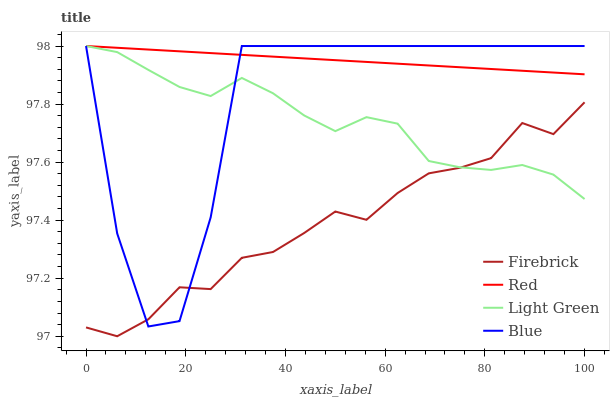Does Firebrick have the minimum area under the curve?
Answer yes or no. Yes. Does Red have the maximum area under the curve?
Answer yes or no. Yes. Does Light Green have the minimum area under the curve?
Answer yes or no. No. Does Light Green have the maximum area under the curve?
Answer yes or no. No. Is Red the smoothest?
Answer yes or no. Yes. Is Blue the roughest?
Answer yes or no. Yes. Is Firebrick the smoothest?
Answer yes or no. No. Is Firebrick the roughest?
Answer yes or no. No. Does Firebrick have the lowest value?
Answer yes or no. Yes. Does Light Green have the lowest value?
Answer yes or no. No. Does Red have the highest value?
Answer yes or no. Yes. Does Firebrick have the highest value?
Answer yes or no. No. Is Firebrick less than Red?
Answer yes or no. Yes. Is Red greater than Firebrick?
Answer yes or no. Yes. Does Blue intersect Light Green?
Answer yes or no. Yes. Is Blue less than Light Green?
Answer yes or no. No. Is Blue greater than Light Green?
Answer yes or no. No. Does Firebrick intersect Red?
Answer yes or no. No. 